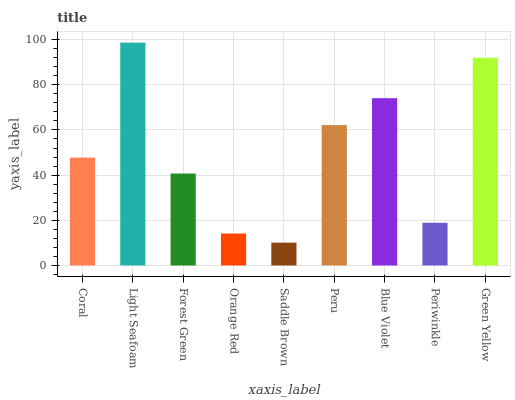Is Saddle Brown the minimum?
Answer yes or no. Yes. Is Light Seafoam the maximum?
Answer yes or no. Yes. Is Forest Green the minimum?
Answer yes or no. No. Is Forest Green the maximum?
Answer yes or no. No. Is Light Seafoam greater than Forest Green?
Answer yes or no. Yes. Is Forest Green less than Light Seafoam?
Answer yes or no. Yes. Is Forest Green greater than Light Seafoam?
Answer yes or no. No. Is Light Seafoam less than Forest Green?
Answer yes or no. No. Is Coral the high median?
Answer yes or no. Yes. Is Coral the low median?
Answer yes or no. Yes. Is Green Yellow the high median?
Answer yes or no. No. Is Green Yellow the low median?
Answer yes or no. No. 